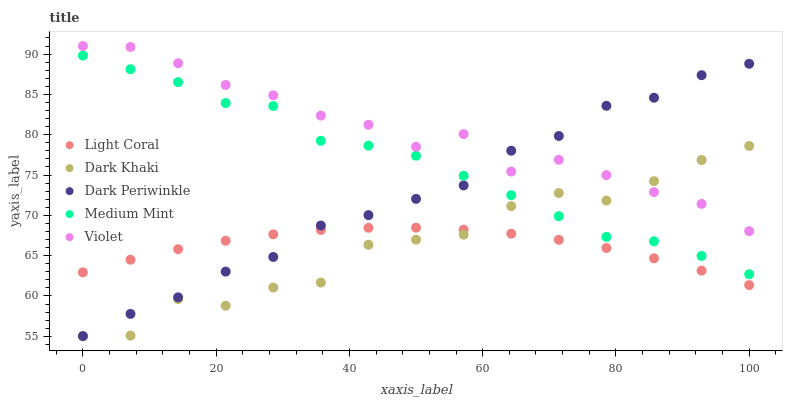Does Light Coral have the minimum area under the curve?
Answer yes or no. Yes. Does Violet have the maximum area under the curve?
Answer yes or no. Yes. Does Dark Khaki have the minimum area under the curve?
Answer yes or no. No. Does Dark Khaki have the maximum area under the curve?
Answer yes or no. No. Is Light Coral the smoothest?
Answer yes or no. Yes. Is Dark Khaki the roughest?
Answer yes or no. Yes. Is Violet the smoothest?
Answer yes or no. No. Is Violet the roughest?
Answer yes or no. No. Does Dark Khaki have the lowest value?
Answer yes or no. Yes. Does Violet have the lowest value?
Answer yes or no. No. Does Violet have the highest value?
Answer yes or no. Yes. Does Dark Khaki have the highest value?
Answer yes or no. No. Is Light Coral less than Violet?
Answer yes or no. Yes. Is Violet greater than Light Coral?
Answer yes or no. Yes. Does Violet intersect Dark Khaki?
Answer yes or no. Yes. Is Violet less than Dark Khaki?
Answer yes or no. No. Is Violet greater than Dark Khaki?
Answer yes or no. No. Does Light Coral intersect Violet?
Answer yes or no. No. 